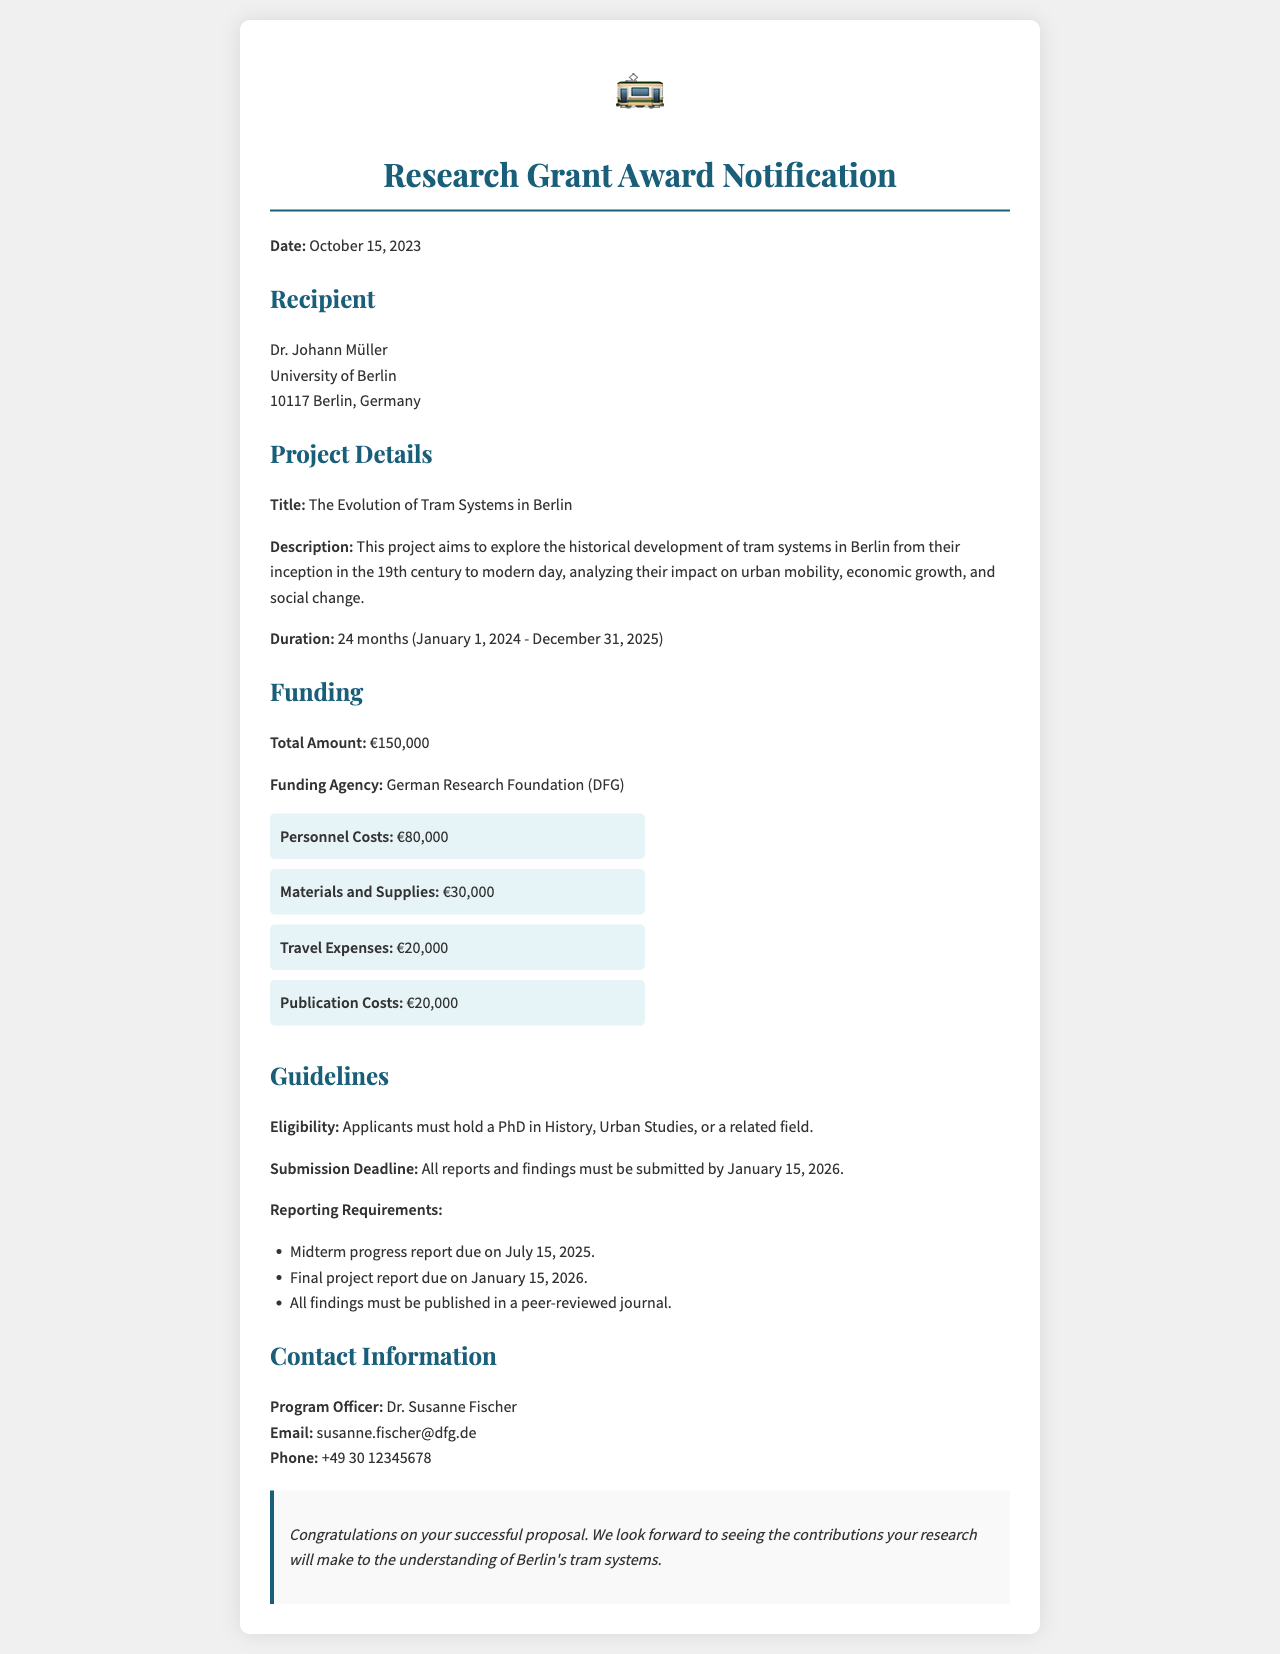What is the title of the project? The title of the project is explicitly stated in the project details section.
Answer: The Evolution of Tram Systems in Berlin Who is the recipient of the grant? The recipient's name and affiliation are provided in the recipient section of the document.
Answer: Dr. Johann Müller What is the total amount of funding awarded? The total funding amount is mentioned in the funding section.
Answer: €150,000 When is the final project report due? The due date for the final project report is specified under the reporting requirements in the guidelines.
Answer: January 15, 2026 What are the travel expenses allocated in the budget? The amount allocated for travel expenses is specified in the funding breakdown.
Answer: €20,000 Which organization is providing the funding? The funding agency is mentioned in the funding section of the document.
Answer: German Research Foundation (DFG) How long is the project scheduled to last? The duration of the project is detailed in the project details section.
Answer: 24 months What is the email address of the program officer? The email address for contact is provided in the contact information.
Answer: susanne.fischer@dfg.de What is required for the midterm progress report? The information required for the midterm report can be inferred from the reporting requirements section.
Answer: Due on July 15, 2025 